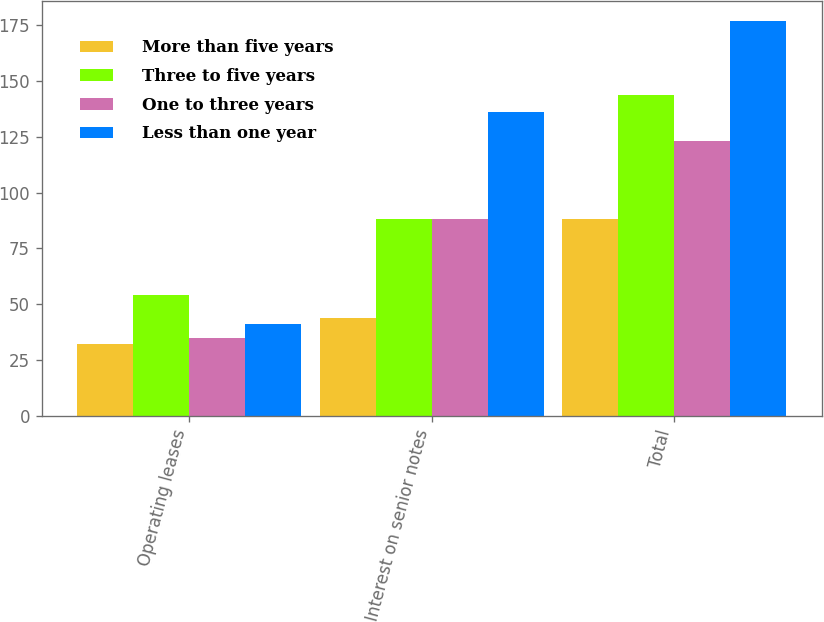Convert chart. <chart><loc_0><loc_0><loc_500><loc_500><stacked_bar_chart><ecel><fcel>Operating leases<fcel>Interest on senior notes<fcel>Total<nl><fcel>More than five years<fcel>32<fcel>44<fcel>88<nl><fcel>Three to five years<fcel>54<fcel>88<fcel>144<nl><fcel>One to three years<fcel>35<fcel>88<fcel>123<nl><fcel>Less than one year<fcel>41<fcel>136<fcel>177<nl></chart> 